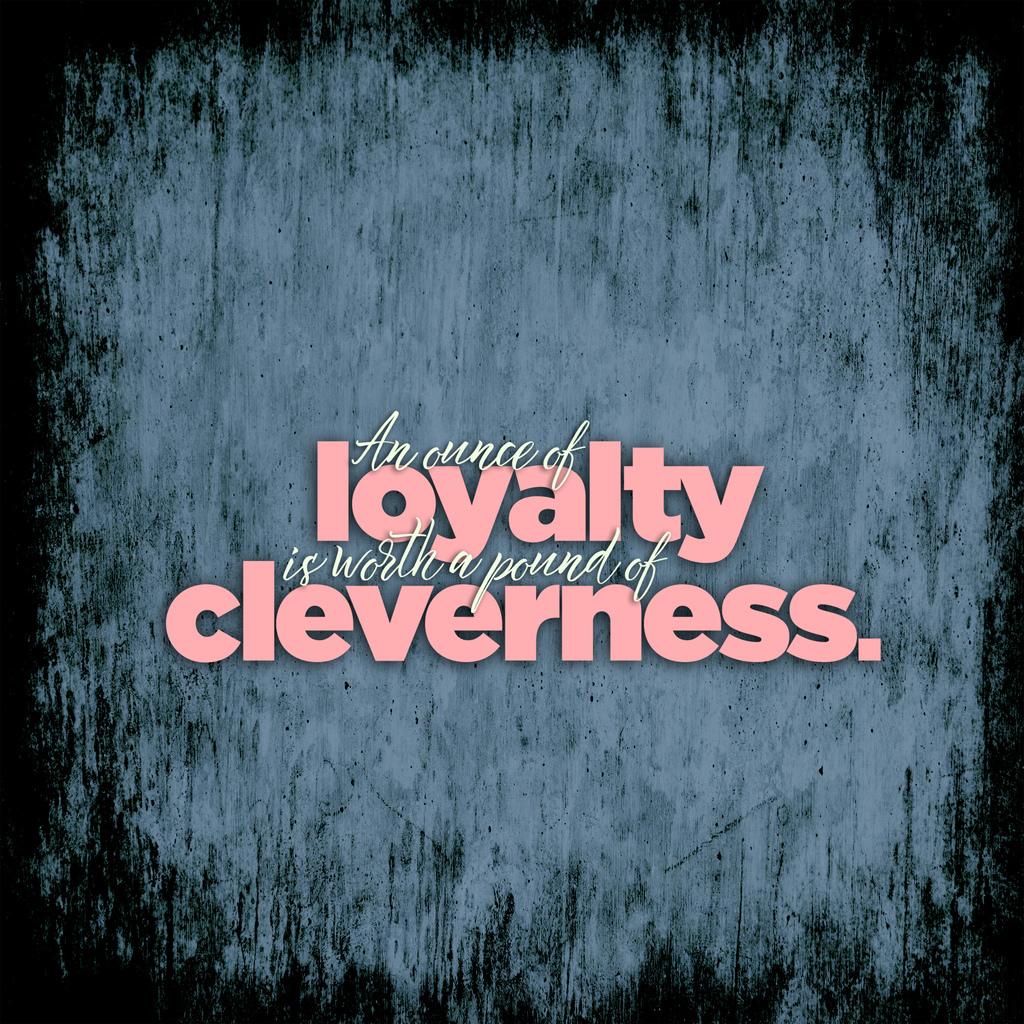What is worth a pound ?
Provide a short and direct response. Cleverness. What 2 words are written in pink?
Provide a succinct answer. Loyalty cleverness. 